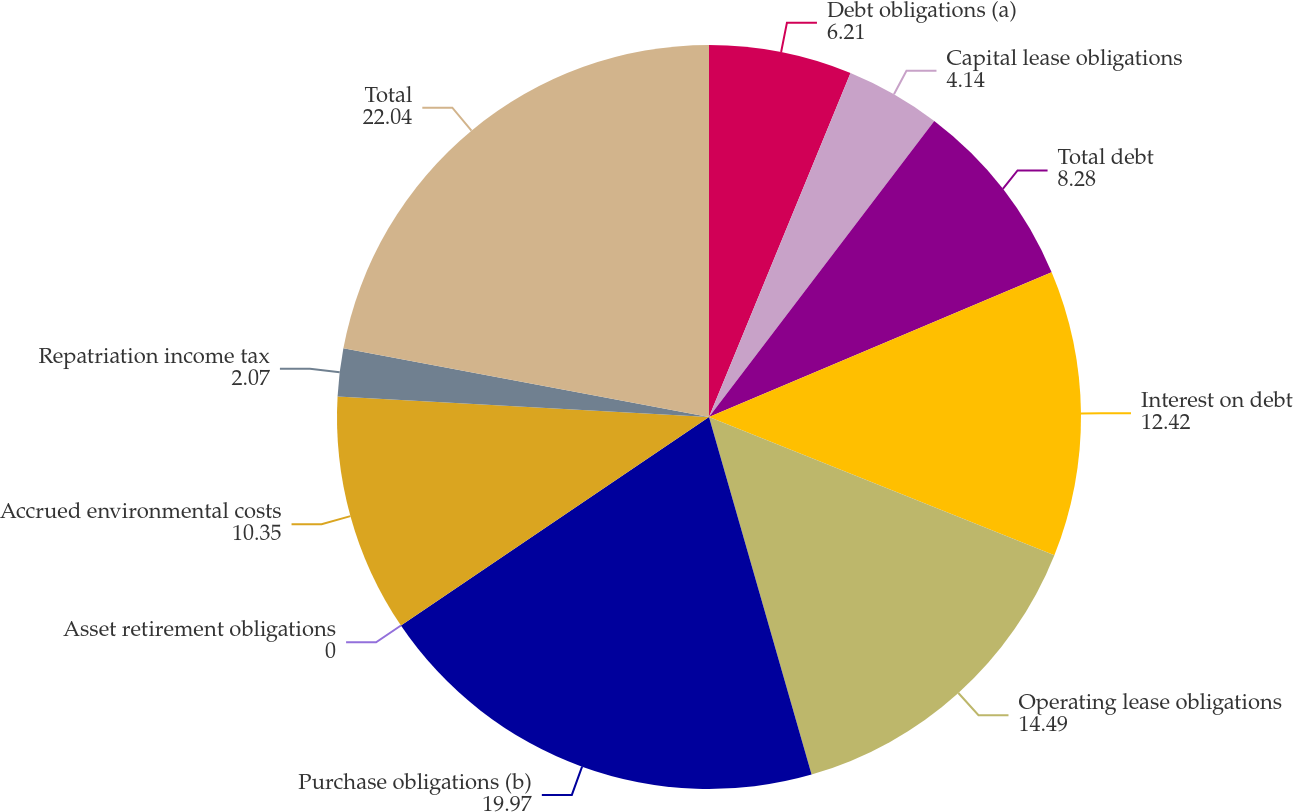<chart> <loc_0><loc_0><loc_500><loc_500><pie_chart><fcel>Debt obligations (a)<fcel>Capital lease obligations<fcel>Total debt<fcel>Interest on debt<fcel>Operating lease obligations<fcel>Purchase obligations (b)<fcel>Asset retirement obligations<fcel>Accrued environmental costs<fcel>Repatriation income tax<fcel>Total<nl><fcel>6.21%<fcel>4.14%<fcel>8.28%<fcel>12.42%<fcel>14.49%<fcel>19.97%<fcel>0.0%<fcel>10.35%<fcel>2.07%<fcel>22.04%<nl></chart> 